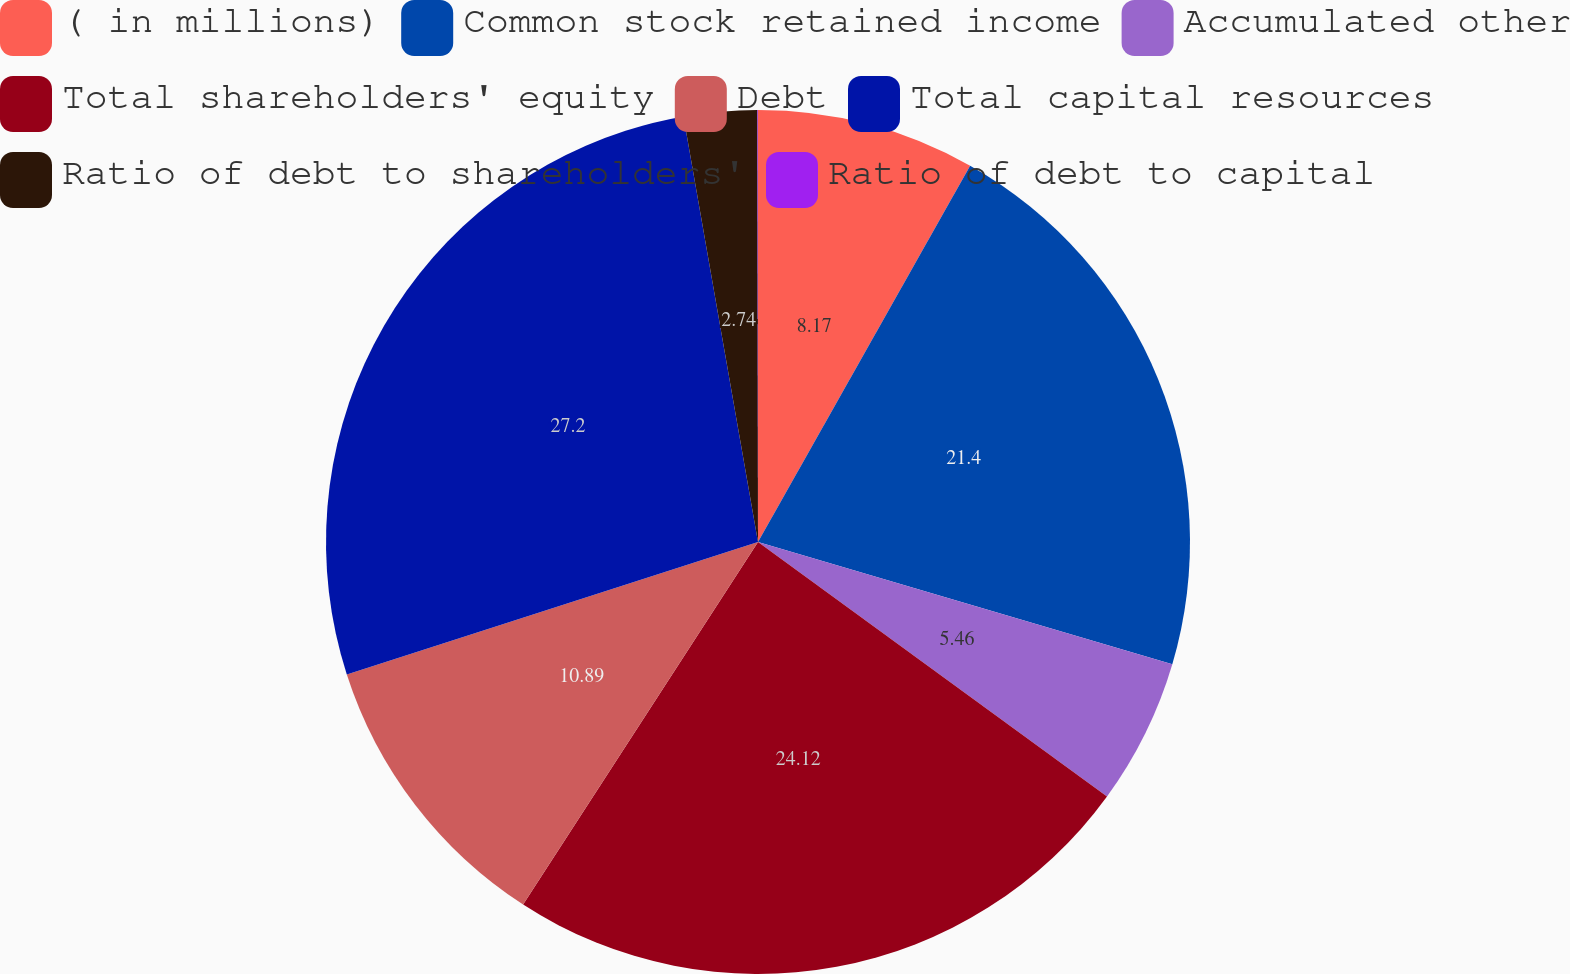Convert chart to OTSL. <chart><loc_0><loc_0><loc_500><loc_500><pie_chart><fcel>( in millions)<fcel>Common stock retained income<fcel>Accumulated other<fcel>Total shareholders' equity<fcel>Debt<fcel>Total capital resources<fcel>Ratio of debt to shareholders'<fcel>Ratio of debt to capital<nl><fcel>8.17%<fcel>21.4%<fcel>5.46%<fcel>24.12%<fcel>10.89%<fcel>27.2%<fcel>2.74%<fcel>0.02%<nl></chart> 